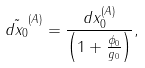Convert formula to latex. <formula><loc_0><loc_0><loc_500><loc_500>\tilde { d x _ { 0 } } ^ { ( A ) } = \frac { d x _ { 0 } ^ { ( A ) } } { \left ( 1 + \frac { \phi _ { 0 } } { g _ { 0 } } \right ) } ,</formula> 